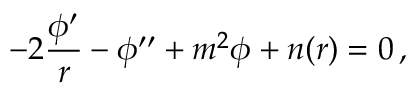<formula> <loc_0><loc_0><loc_500><loc_500>- 2 \frac { \phi ^ { \prime } } r - \phi ^ { \prime \prime } + m ^ { 2 } \phi + n ( r ) = 0 \, ,</formula> 